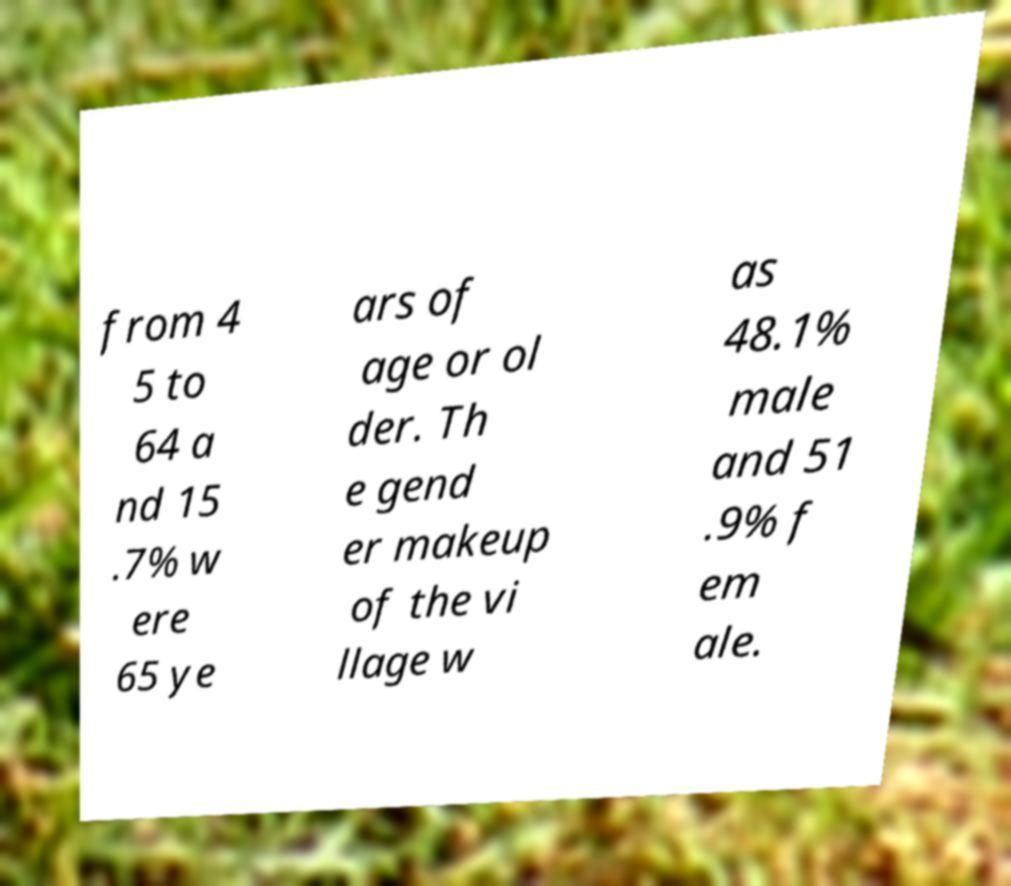Could you assist in decoding the text presented in this image and type it out clearly? from 4 5 to 64 a nd 15 .7% w ere 65 ye ars of age or ol der. Th e gend er makeup of the vi llage w as 48.1% male and 51 .9% f em ale. 